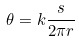<formula> <loc_0><loc_0><loc_500><loc_500>\theta = k \frac { s } { 2 \pi r }</formula> 